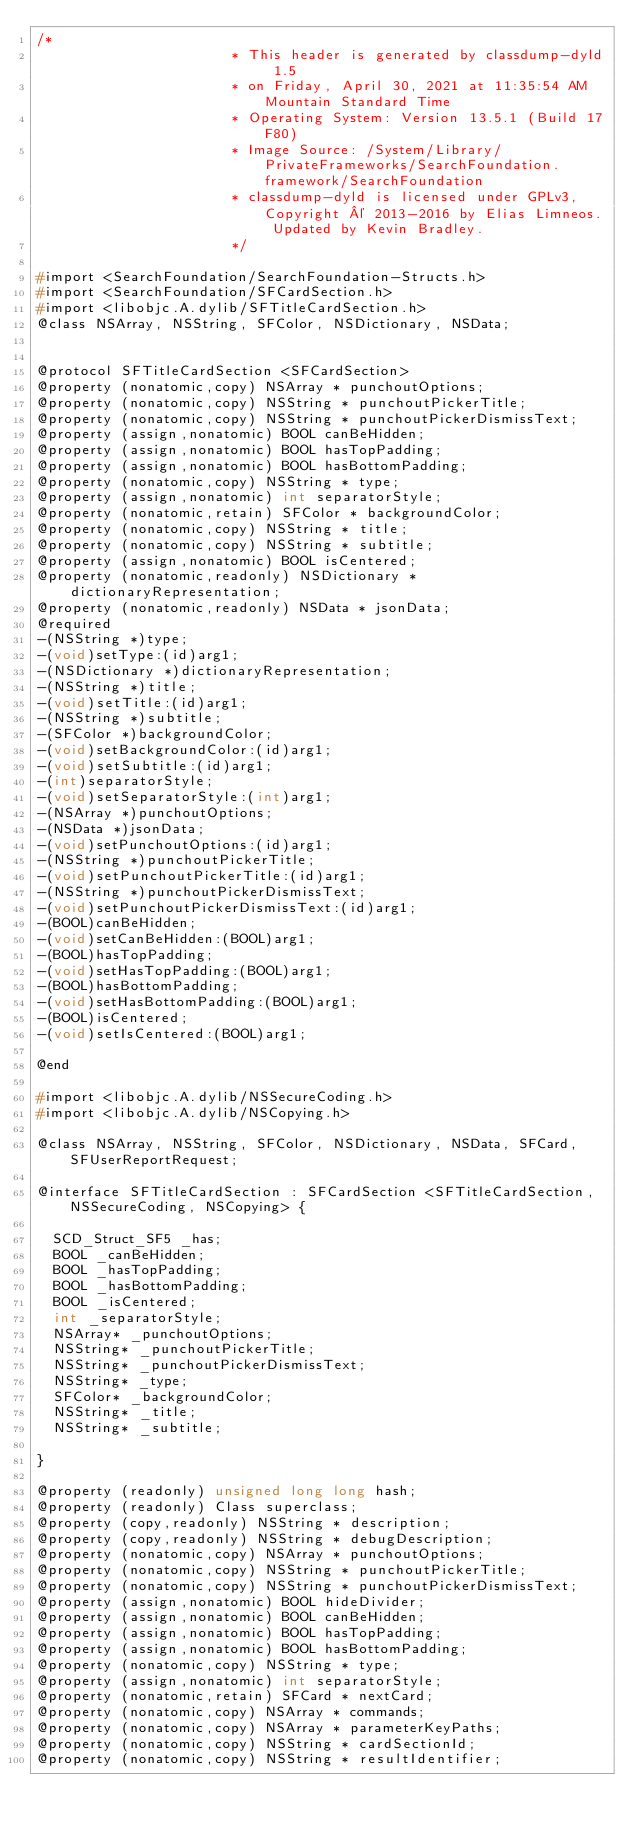<code> <loc_0><loc_0><loc_500><loc_500><_C_>/*
                       * This header is generated by classdump-dyld 1.5
                       * on Friday, April 30, 2021 at 11:35:54 AM Mountain Standard Time
                       * Operating System: Version 13.5.1 (Build 17F80)
                       * Image Source: /System/Library/PrivateFrameworks/SearchFoundation.framework/SearchFoundation
                       * classdump-dyld is licensed under GPLv3, Copyright © 2013-2016 by Elias Limneos. Updated by Kevin Bradley.
                       */

#import <SearchFoundation/SearchFoundation-Structs.h>
#import <SearchFoundation/SFCardSection.h>
#import <libobjc.A.dylib/SFTitleCardSection.h>
@class NSArray, NSString, SFColor, NSDictionary, NSData;


@protocol SFTitleCardSection <SFCardSection>
@property (nonatomic,copy) NSArray * punchoutOptions; 
@property (nonatomic,copy) NSString * punchoutPickerTitle; 
@property (nonatomic,copy) NSString * punchoutPickerDismissText; 
@property (assign,nonatomic) BOOL canBeHidden; 
@property (assign,nonatomic) BOOL hasTopPadding; 
@property (assign,nonatomic) BOOL hasBottomPadding; 
@property (nonatomic,copy) NSString * type; 
@property (assign,nonatomic) int separatorStyle; 
@property (nonatomic,retain) SFColor * backgroundColor; 
@property (nonatomic,copy) NSString * title; 
@property (nonatomic,copy) NSString * subtitle; 
@property (assign,nonatomic) BOOL isCentered; 
@property (nonatomic,readonly) NSDictionary * dictionaryRepresentation; 
@property (nonatomic,readonly) NSData * jsonData; 
@required
-(NSString *)type;
-(void)setType:(id)arg1;
-(NSDictionary *)dictionaryRepresentation;
-(NSString *)title;
-(void)setTitle:(id)arg1;
-(NSString *)subtitle;
-(SFColor *)backgroundColor;
-(void)setBackgroundColor:(id)arg1;
-(void)setSubtitle:(id)arg1;
-(int)separatorStyle;
-(void)setSeparatorStyle:(int)arg1;
-(NSArray *)punchoutOptions;
-(NSData *)jsonData;
-(void)setPunchoutOptions:(id)arg1;
-(NSString *)punchoutPickerTitle;
-(void)setPunchoutPickerTitle:(id)arg1;
-(NSString *)punchoutPickerDismissText;
-(void)setPunchoutPickerDismissText:(id)arg1;
-(BOOL)canBeHidden;
-(void)setCanBeHidden:(BOOL)arg1;
-(BOOL)hasTopPadding;
-(void)setHasTopPadding:(BOOL)arg1;
-(BOOL)hasBottomPadding;
-(void)setHasBottomPadding:(BOOL)arg1;
-(BOOL)isCentered;
-(void)setIsCentered:(BOOL)arg1;

@end

#import <libobjc.A.dylib/NSSecureCoding.h>
#import <libobjc.A.dylib/NSCopying.h>

@class NSArray, NSString, SFColor, NSDictionary, NSData, SFCard, SFUserReportRequest;

@interface SFTitleCardSection : SFCardSection <SFTitleCardSection, NSSecureCoding, NSCopying> {

	SCD_Struct_SF5 _has;
	BOOL _canBeHidden;
	BOOL _hasTopPadding;
	BOOL _hasBottomPadding;
	BOOL _isCentered;
	int _separatorStyle;
	NSArray* _punchoutOptions;
	NSString* _punchoutPickerTitle;
	NSString* _punchoutPickerDismissText;
	NSString* _type;
	SFColor* _backgroundColor;
	NSString* _title;
	NSString* _subtitle;

}

@property (readonly) unsigned long long hash; 
@property (readonly) Class superclass; 
@property (copy,readonly) NSString * description; 
@property (copy,readonly) NSString * debugDescription; 
@property (nonatomic,copy) NSArray * punchoutOptions; 
@property (nonatomic,copy) NSString * punchoutPickerTitle; 
@property (nonatomic,copy) NSString * punchoutPickerDismissText; 
@property (assign,nonatomic) BOOL hideDivider; 
@property (assign,nonatomic) BOOL canBeHidden; 
@property (assign,nonatomic) BOOL hasTopPadding; 
@property (assign,nonatomic) BOOL hasBottomPadding; 
@property (nonatomic,copy) NSString * type; 
@property (assign,nonatomic) int separatorStyle; 
@property (nonatomic,retain) SFCard * nextCard; 
@property (nonatomic,copy) NSArray * commands; 
@property (nonatomic,copy) NSArray * parameterKeyPaths; 
@property (nonatomic,copy) NSString * cardSectionId; 
@property (nonatomic,copy) NSString * resultIdentifier; </code> 